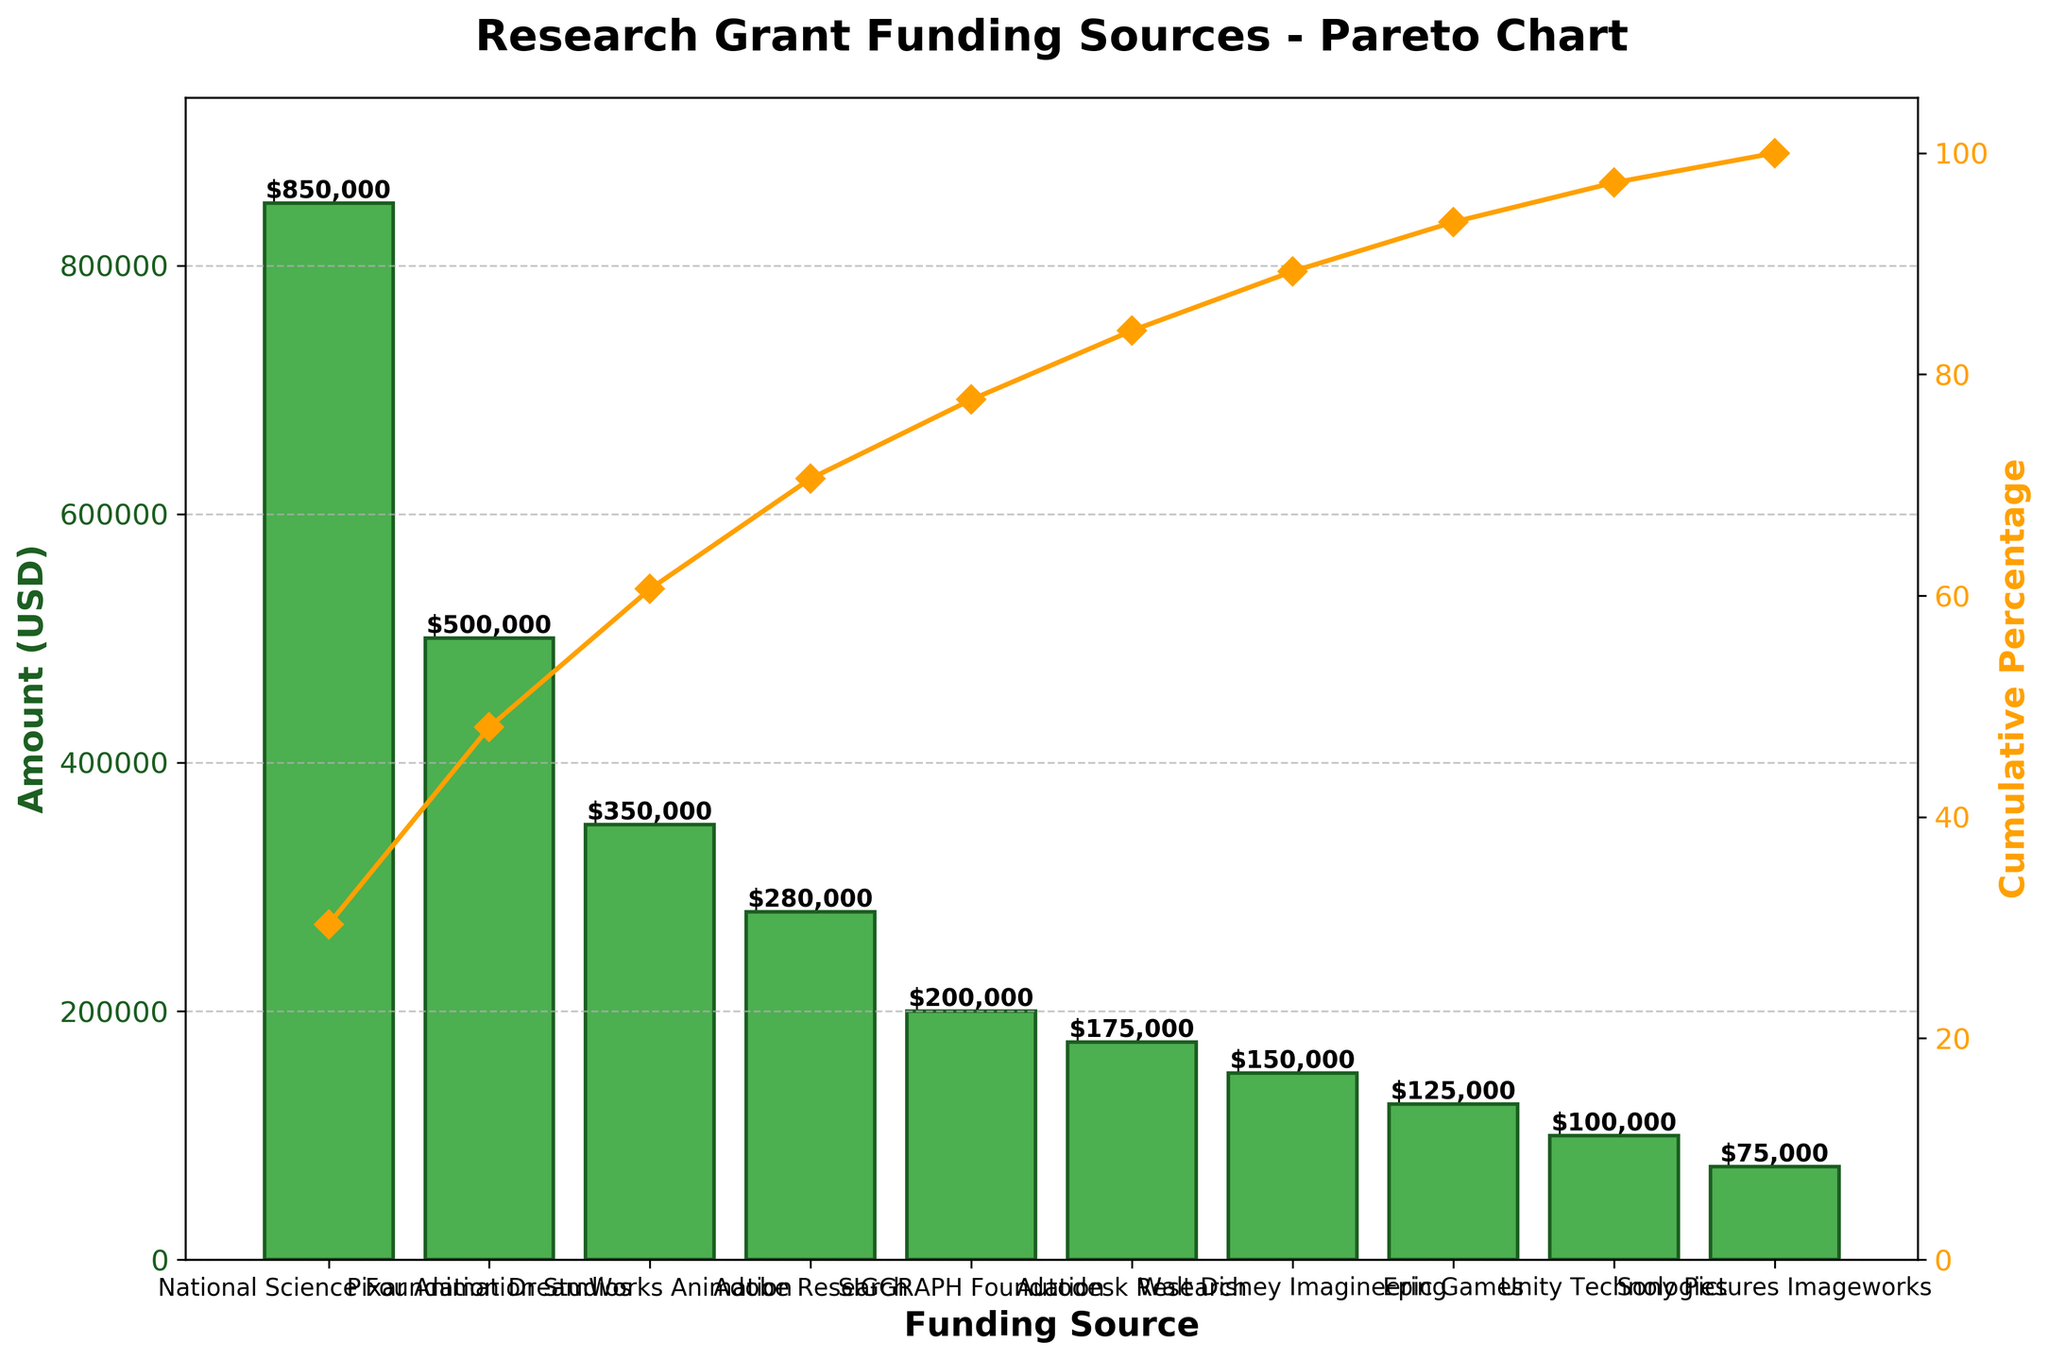What is the title of the Pareto chart? The title of a graph is usually located at the top and provides a brief description of its content. In this Pareto chart, the title succinctly describes what the chart is about.
Answer: Research Grant Funding Sources - Pareto Chart What is the funding amount from DreamWorks Animation? To find the funding amount from DreamWorks Animation, locate its corresponding bar on the x-axis, and read the height of the bar on the y-axis labeled "Amount (USD)."
Answer: $350,000 Which funding source contributed the highest amount? To determine the highest contributing funding source, identify the tallest bar on the chart. The label on the x-axis of this bar represents the funding source.
Answer: National Science Foundation What percentage of the total funding is contributed by the top three funding sources? To find this, first identify the top three bars: National Science Foundation ($850,000), Pixar Animation Studios ($500,000), and DreamWorks Animation ($350,000). Add these amounts: $850,000 + $500,000 + $350,000 = $1,700,000. The total funding is $2,805,000. Calculate the percentage: ($1,700,000 / $2,805,000) x 100 ≈ 60.6%.
Answer: 60.6% What is the cumulative percentage at the funding source Autodesk Research? To find this, follow the curve for cumulative percentage on the second y-axis and locate the point corresponding to Autodesk Research on the x-axis. Read the value on the y-axis labeled "Cumulative Percentage."
Answer: 78.4% How many funding sources are listed in this chart? Count the number of labels along the x-axis, which represent different funding sources.
Answer: 10 What is the cumulative percentage after adding the contributions from National Science Foundation and Pixar Animation Studios? To calculate this, add the amounts from National Science Foundation ($850,000) and Pixar Animation Studios ($500,000) together to get $1,350,000. Then, divide this by the total funding $2,805,000 and multiply by 100 to get the cumulative percentage: ($1,350,000 / $2,805,000) x 100 ≈ 48.1%.
Answer: 48.1% Which funding source contributes less: Unity Technologies or Adobe Research? Compare the heights of the bars for Unity Technologies and Adobe Research. The shorter bar indicates the lower contribution. Unity Technologies has a lower bar than Adobe Research.
Answer: Unity Technologies What is the difference in the amount of funding between SIGGRAPH Foundation and Walt Disney Imagineering? Identify the heights of the bars for SIGGRAPH Foundation ($200,000) and Walt Disney Imagineering ($150,000) and subtract the smaller amount from the larger amount: $200,000 - $150,000 = $50,000.
Answer: $50,000 What is the cumulative percentage disclosed by the Epic Games funding source? Follow the cumulative percentage line to the point representing Epic Games on the x-axis. Read the cumulative percentage value on the right y-axis.
Answer: 86.7% 